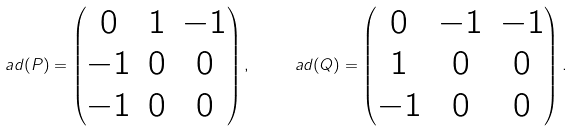Convert formula to latex. <formula><loc_0><loc_0><loc_500><loc_500>\ a d ( P ) = \begin{pmatrix} 0 & 1 & - 1 \\ - 1 & 0 & 0 \\ - 1 & 0 & 0 \end{pmatrix} , \quad \ a d ( Q ) = \begin{pmatrix} 0 & - 1 & - 1 \\ 1 & 0 & 0 \\ - 1 & 0 & 0 \end{pmatrix} .</formula> 